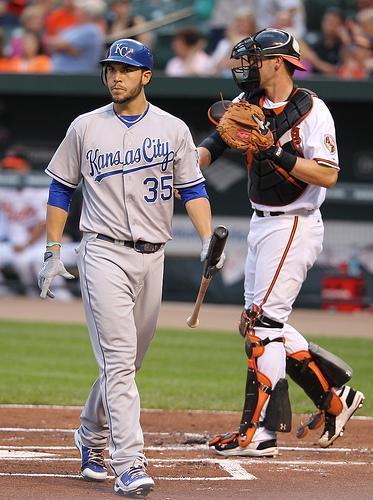How many players are shown?
Give a very brief answer. 2. 